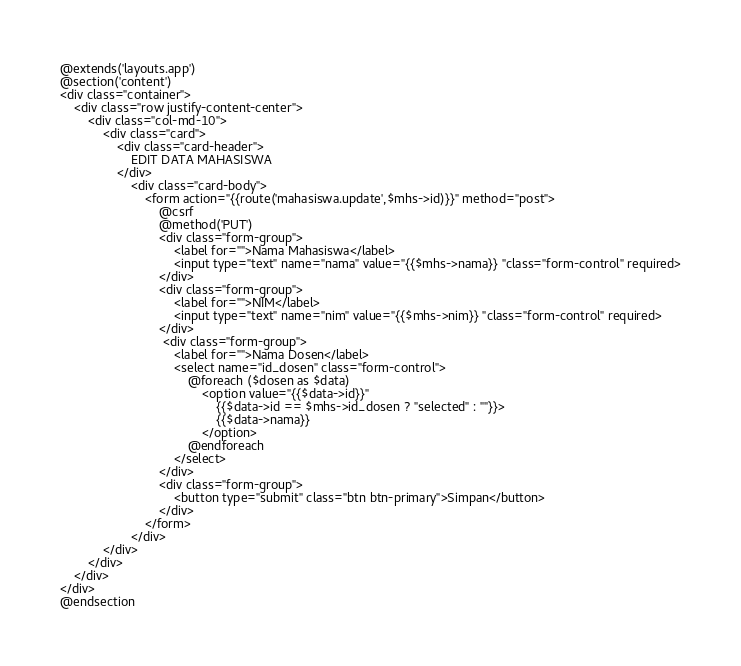Convert code to text. <code><loc_0><loc_0><loc_500><loc_500><_PHP_>@extends('layouts.app')
@section('content')
<div class="container">
    <div class="row justify-content-center">
        <div class="col-md-10">
            <div class="card">
                <div class="card-header">
                    EDIT DATA MAHASISWA
                </div>
                    <div class="card-body">
                        <form action="{{route('mahasiswa.update',$mhs->id)}}" method="post">
                            @csrf
                            @method('PUT')
                            <div class="form-group">
                                <label for="">Nama Mahasiswa</label>
                                <input type="text" name="nama" value="{{$mhs->nama}} "class="form-control" required>
                            </div>
                            <div class="form-group">
                                <label for="">NIM</label>
                                <input type="text" name="nim" value="{{$mhs->nim}} "class="form-control" required>
                            </div>
                             <div class="form-group">
                                <label for="">Nama Dosen</label>
                                <select name="id_dosen" class="form-control">
                                    @foreach ($dosen as $data)
                                        <option value="{{$data->id}}"
                                            {{$data->id == $mhs->id_dosen ? "selected" : ""}}>
                                            {{$data->nama}}
                                        </option>
                                    @endforeach
                                </select>
                            </div>
                            <div class="form-group">
                                <button type="submit" class="btn btn-primary">Simpan</button>
                            </div>
                        </form>
                    </div>
            </div>
        </div>
    </div>
</div>
@endsection

</code> 